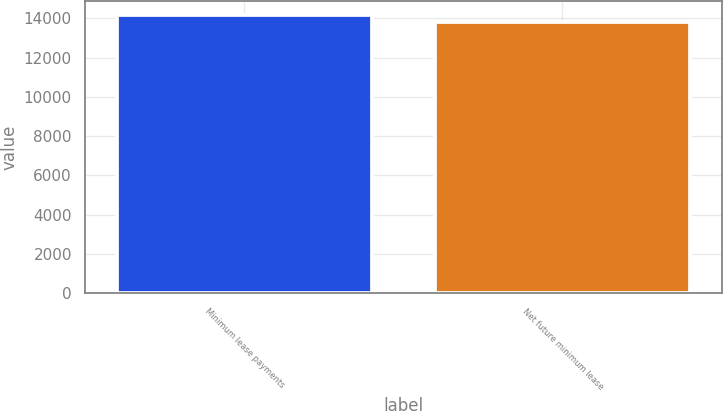Convert chart. <chart><loc_0><loc_0><loc_500><loc_500><bar_chart><fcel>Minimum lease payments<fcel>Net future minimum lease<nl><fcel>14151<fcel>13812<nl></chart> 